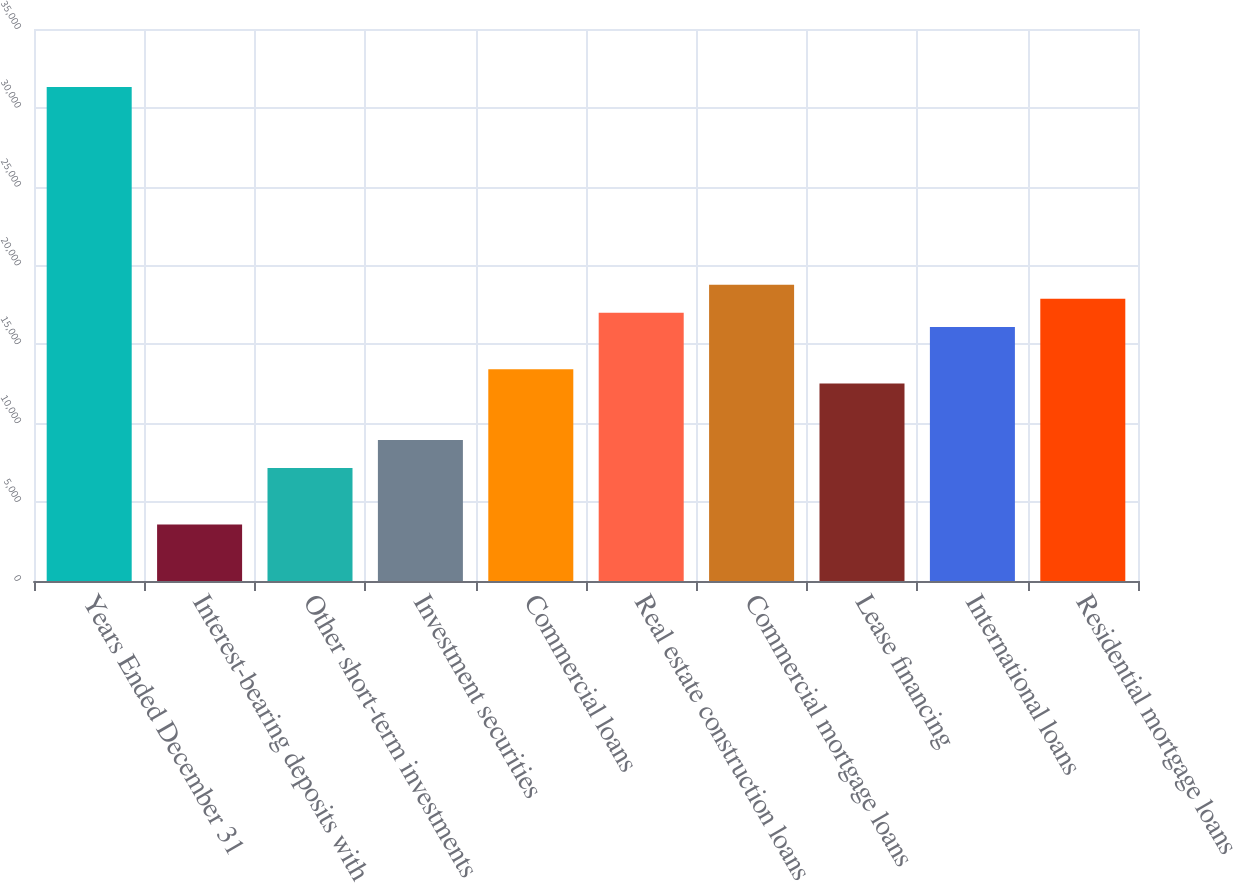<chart> <loc_0><loc_0><loc_500><loc_500><bar_chart><fcel>Years Ended December 31<fcel>Interest-bearing deposits with<fcel>Other short-term investments<fcel>Investment securities<fcel>Commercial loans<fcel>Real estate construction loans<fcel>Commercial mortgage loans<fcel>Lease financing<fcel>International loans<fcel>Residential mortgage loans<nl><fcel>31317.7<fcel>3579.23<fcel>7158.39<fcel>8947.97<fcel>13421.9<fcel>17001.1<fcel>18790.7<fcel>12527.1<fcel>16106.3<fcel>17895.9<nl></chart> 